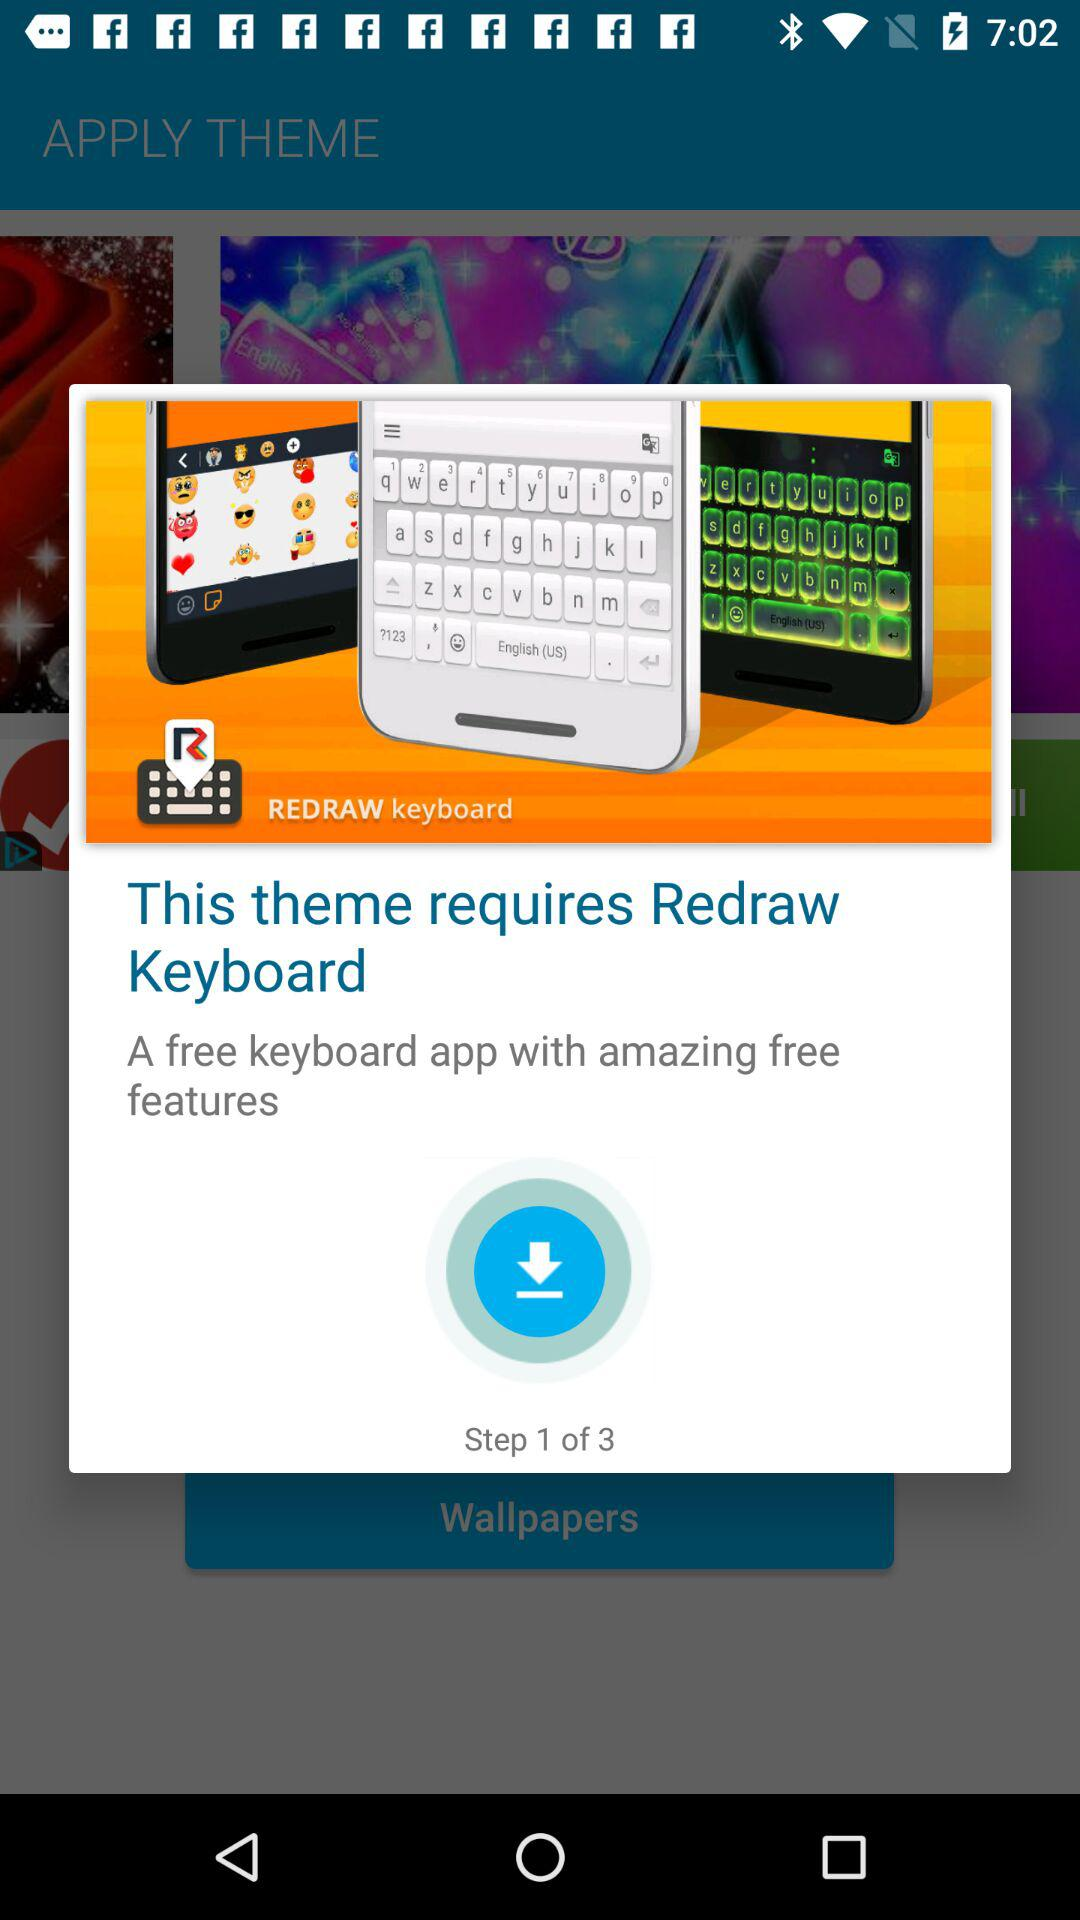What is the name of the application? The name of the application is "REDRAW keyboard". 